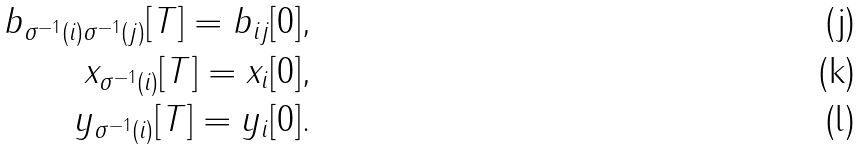Convert formula to latex. <formula><loc_0><loc_0><loc_500><loc_500>b _ { \sigma ^ { - 1 } ( i ) \sigma ^ { - 1 } ( j ) } [ T ] = b _ { i j } [ 0 ] , \\ x _ { \sigma ^ { - 1 } ( i ) } [ T ] = x _ { i } [ 0 ] , \\ y _ { \sigma ^ { - 1 } ( i ) } [ T ] = y _ { i } [ 0 ] .</formula> 